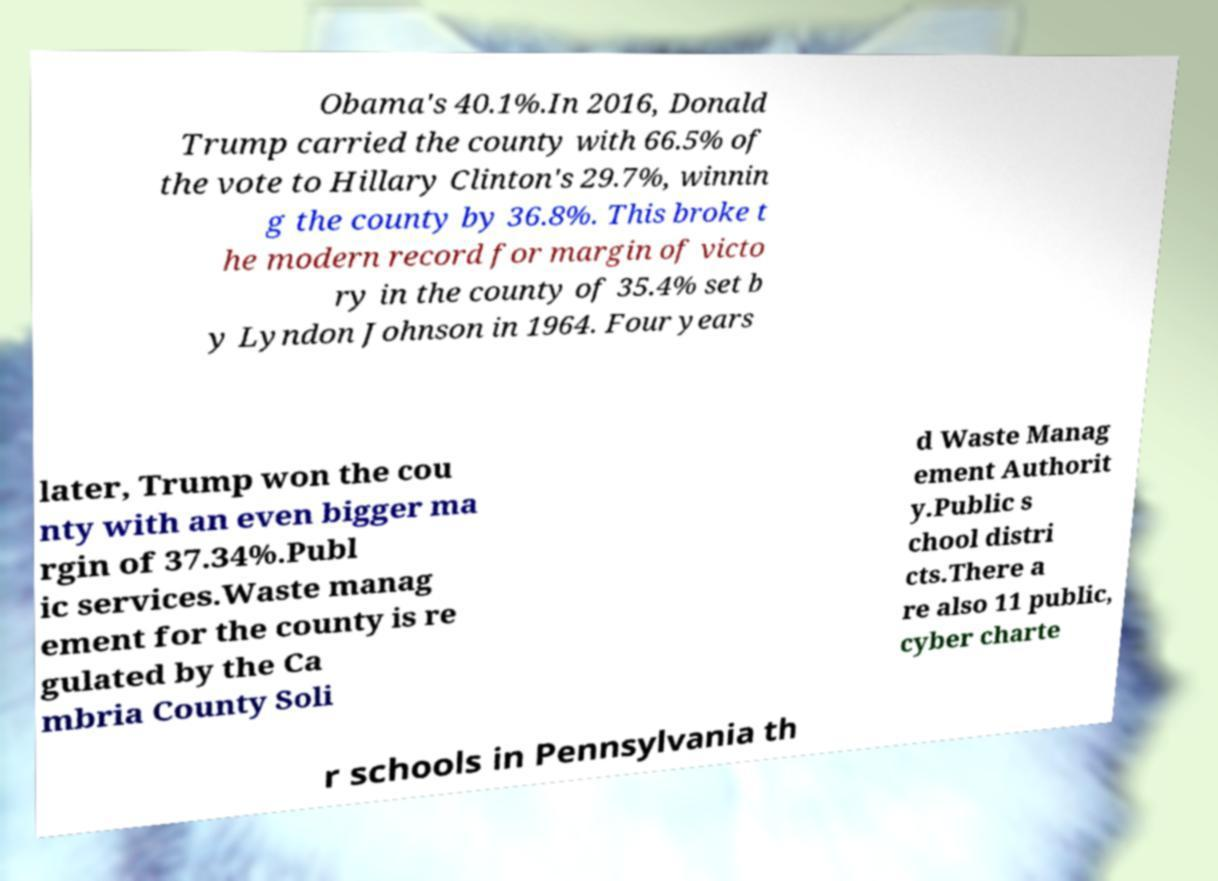For documentation purposes, I need the text within this image transcribed. Could you provide that? Obama's 40.1%.In 2016, Donald Trump carried the county with 66.5% of the vote to Hillary Clinton's 29.7%, winnin g the county by 36.8%. This broke t he modern record for margin of victo ry in the county of 35.4% set b y Lyndon Johnson in 1964. Four years later, Trump won the cou nty with an even bigger ma rgin of 37.34%.Publ ic services.Waste manag ement for the county is re gulated by the Ca mbria County Soli d Waste Manag ement Authorit y.Public s chool distri cts.There a re also 11 public, cyber charte r schools in Pennsylvania th 